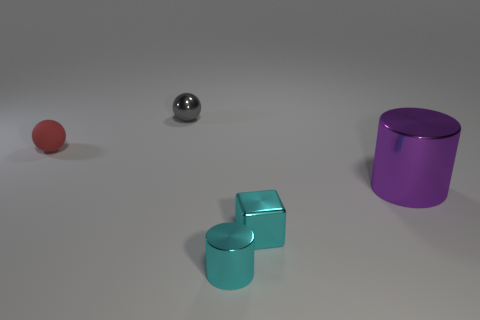Can you describe the spatial arrangement of the objects? Certainly, the image depicts four objects arrayed across the frame on a flat surface. On the left, there's a small red sphere. Moving to the right, there’s a shiny metallic sphere with a reflective surface. Next, we see two small cyan cubes aligned diagonally, and finally, a purple metallic cylinder stands on the far right. 